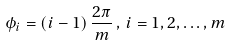<formula> <loc_0><loc_0><loc_500><loc_500>\phi _ { i } = ( i - 1 ) \, \frac { 2 \pi } { m } \, , \, i = 1 , 2 , \dots , m</formula> 